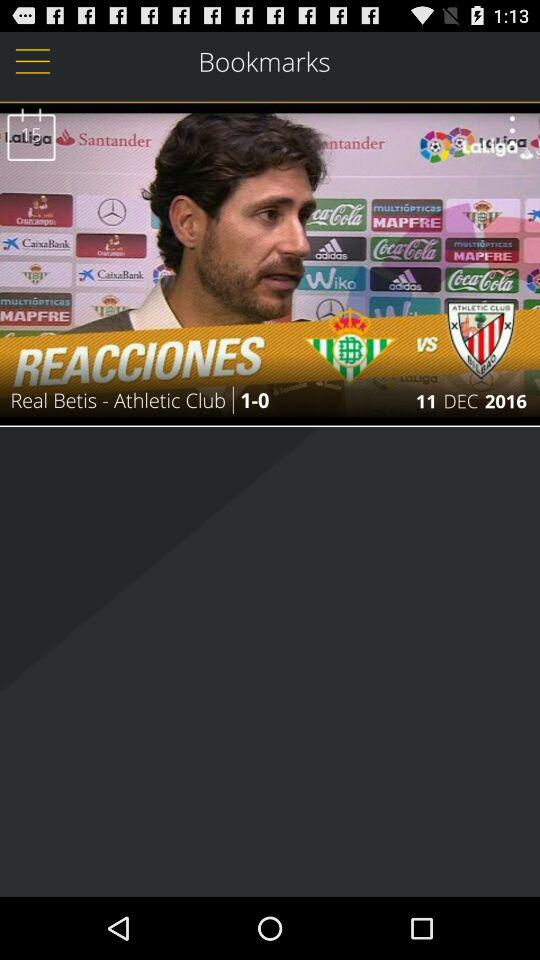Which team played the match in 2016? The teams are "Real Betis" and "Athletic Club". 